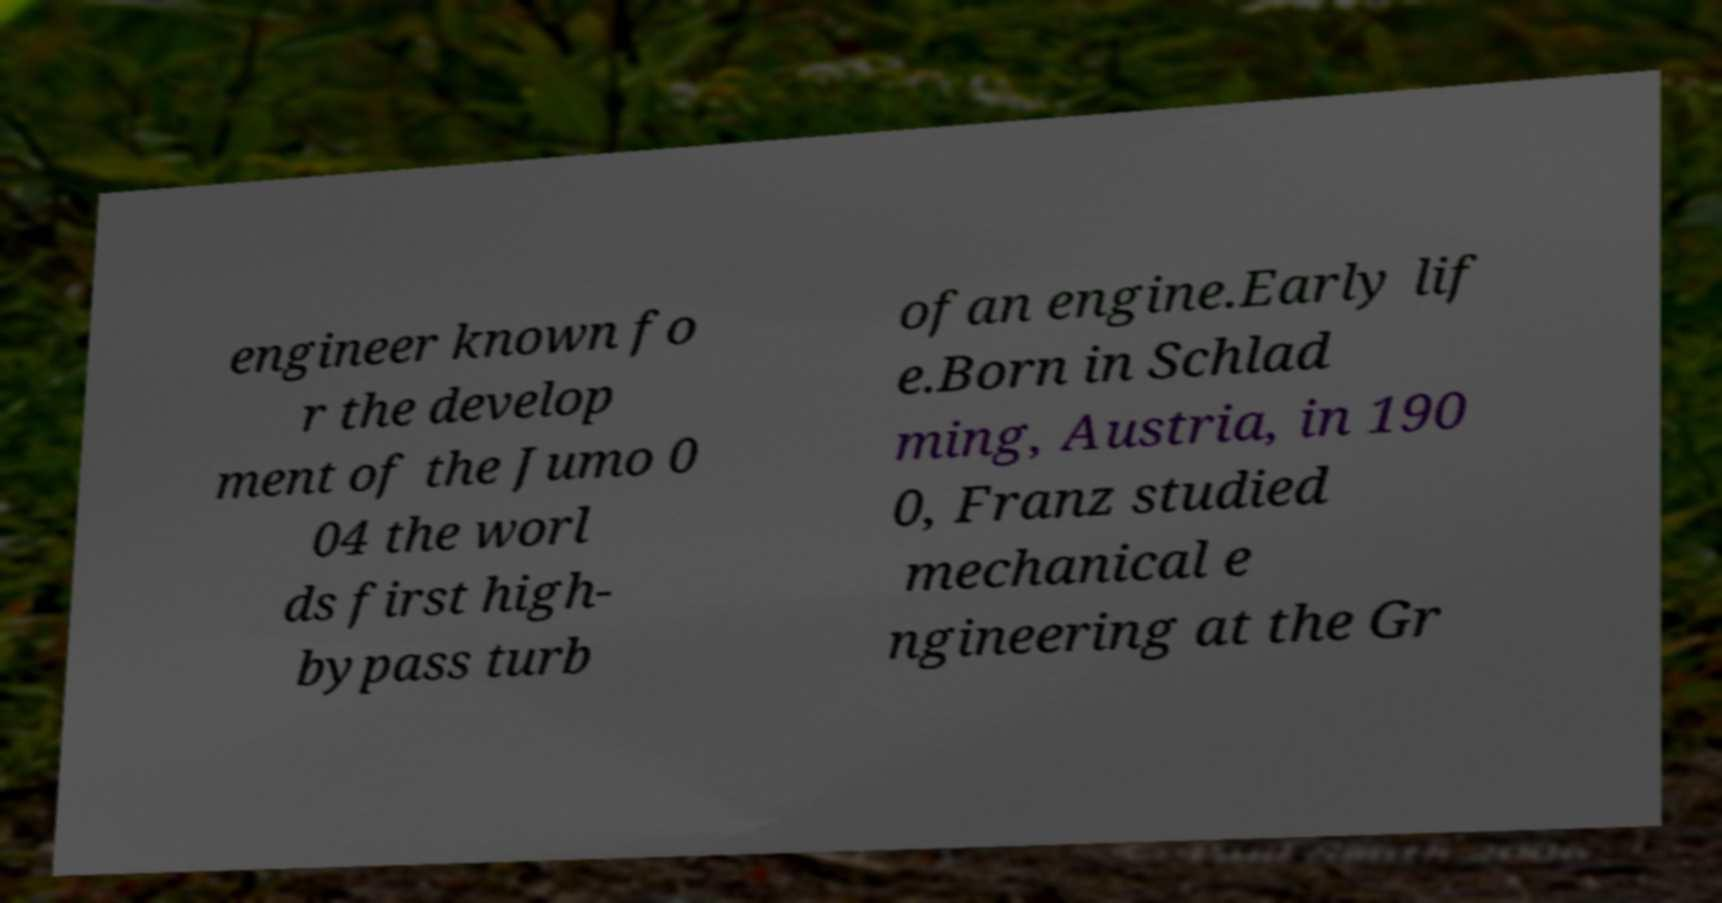Can you read and provide the text displayed in the image?This photo seems to have some interesting text. Can you extract and type it out for me? engineer known fo r the develop ment of the Jumo 0 04 the worl ds first high- bypass turb ofan engine.Early lif e.Born in Schlad ming, Austria, in 190 0, Franz studied mechanical e ngineering at the Gr 